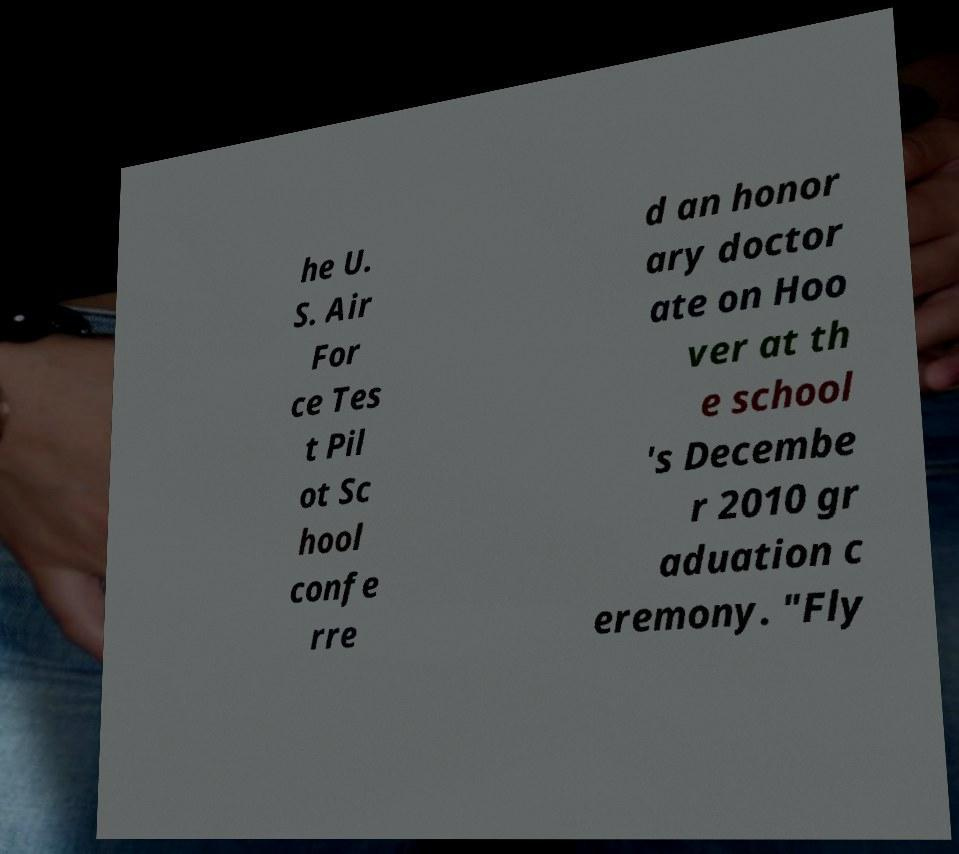There's text embedded in this image that I need extracted. Can you transcribe it verbatim? he U. S. Air For ce Tes t Pil ot Sc hool confe rre d an honor ary doctor ate on Hoo ver at th e school 's Decembe r 2010 gr aduation c eremony. "Fly 